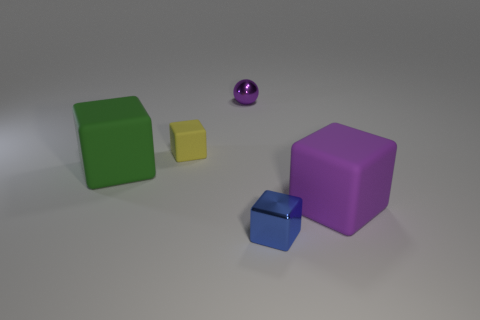There is a small block left of the blue cube; are there any blocks to the right of it?
Give a very brief answer. Yes. How many small brown matte objects are there?
Offer a terse response. 0. There is a block that is both to the right of the small purple metal thing and left of the purple rubber object; what is its color?
Give a very brief answer. Blue. There is a green thing that is the same shape as the yellow matte object; what is its size?
Your response must be concise. Large. What number of purple metal balls have the same size as the yellow thing?
Your answer should be compact. 1. What material is the purple block?
Offer a very short reply. Rubber. There is a big purple cube; are there any small blue things left of it?
Make the answer very short. Yes. There is a object that is the same material as the tiny purple ball; what is its size?
Your response must be concise. Small. How many large things are the same color as the small ball?
Make the answer very short. 1. Are there fewer tiny rubber things in front of the small rubber cube than large purple matte things that are right of the tiny purple object?
Offer a terse response. Yes. 